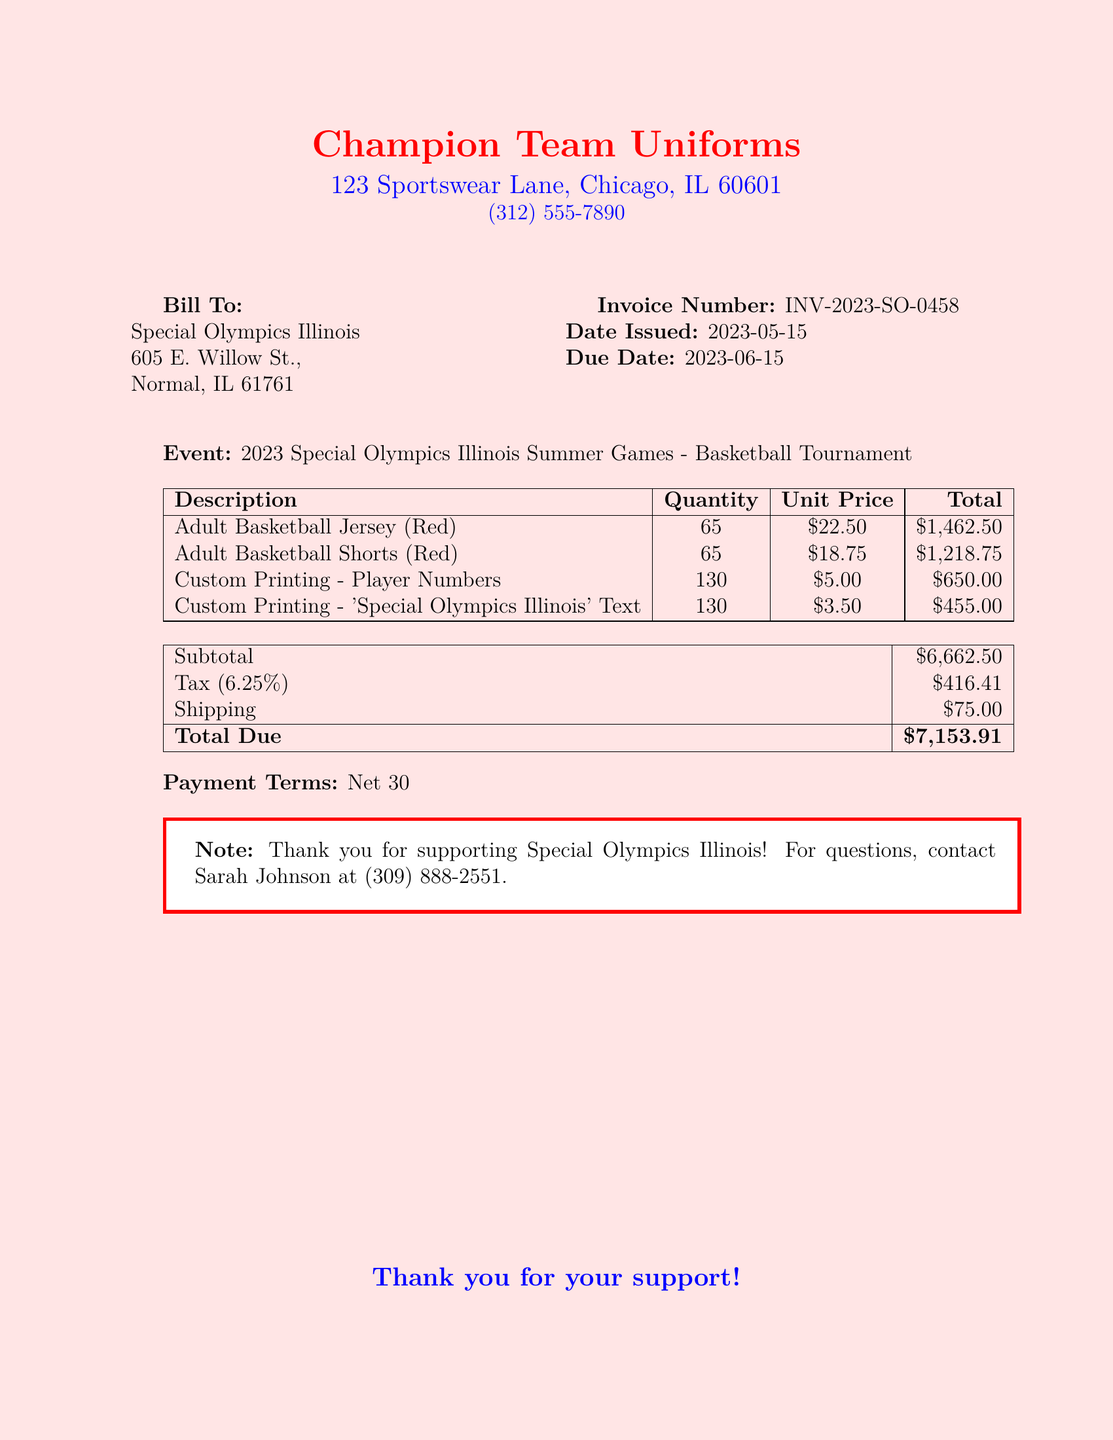What is the invoice number? The invoice number is a unique identifier for the bill, which in this case is INV-2023-SO-0458.
Answer: INV-2023-SO-0458 What is the due date of the invoice? The due date is the deadline for payment, which is provided in the document as 2023-06-15.
Answer: 2023-06-15 How many adult basketball jerseys were ordered? The quantity for adult basketball jerseys is specified in the document, which states that 65 were ordered.
Answer: 65 What is the total amount due for the invoice? The total amount due is summed at the bottom of the invoice, which is listed as $7,153.91.
Answer: $7,153.91 What is the tax percentage applied? The tax percentage is mentioned in the invoice breakdown as 6.25%, which can be found under the tax section.
Answer: 6.25% What is the subtotal before tax? The subtotal is the sum of the items before tax is added, stated as $6,662.50 in the document.
Answer: $6,662.50 Who can be contacted for questions regarding the invoice? The document mentions Sarah Johnson as the contact person for questions, along with her phone number.
Answer: Sarah Johnson What type of event is this invoice for? The event type is clearly mentioned in the document as the 2023 Special Olympics Illinois Summer Games - Basketball Tournament.
Answer: 2023 Special Olympics Illinois Summer Games - Basketball Tournament What is the shipping charge? The shipping cost is explicitly listed on the invoice as $75.00.
Answer: $75.00 